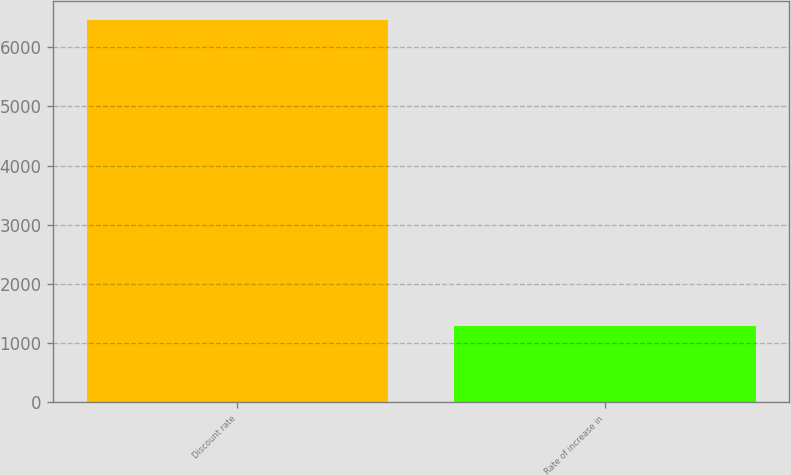<chart> <loc_0><loc_0><loc_500><loc_500><bar_chart><fcel>Discount rate<fcel>Rate of increase in<nl><fcel>6460<fcel>1283<nl></chart> 